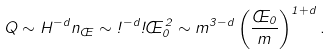<formula> <loc_0><loc_0><loc_500><loc_500>Q \sim H ^ { - d } n _ { \phi } \sim \omega ^ { - d } \omega \phi _ { 0 } ^ { 2 } \sim m ^ { 3 - d } \left ( \frac { \phi _ { 0 } } { m } \right ) ^ { 1 + d } .</formula> 